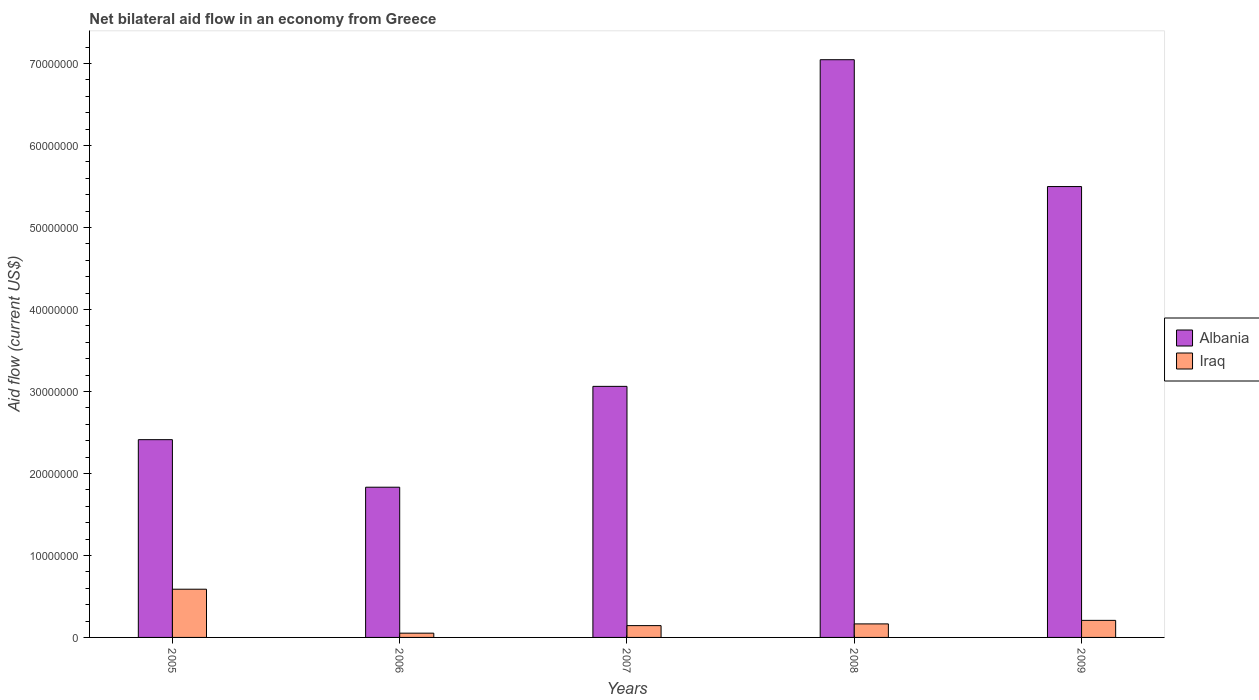How many different coloured bars are there?
Ensure brevity in your answer.  2. How many groups of bars are there?
Give a very brief answer. 5. Are the number of bars per tick equal to the number of legend labels?
Your answer should be compact. Yes. Are the number of bars on each tick of the X-axis equal?
Provide a succinct answer. Yes. What is the label of the 4th group of bars from the left?
Provide a short and direct response. 2008. In how many cases, is the number of bars for a given year not equal to the number of legend labels?
Offer a terse response. 0. What is the net bilateral aid flow in Albania in 2005?
Your response must be concise. 2.41e+07. Across all years, what is the maximum net bilateral aid flow in Iraq?
Make the answer very short. 5.88e+06. Across all years, what is the minimum net bilateral aid flow in Albania?
Offer a terse response. 1.83e+07. In which year was the net bilateral aid flow in Iraq minimum?
Give a very brief answer. 2006. What is the total net bilateral aid flow in Iraq in the graph?
Offer a terse response. 1.16e+07. What is the difference between the net bilateral aid flow in Iraq in 2008 and that in 2009?
Ensure brevity in your answer.  -4.30e+05. What is the difference between the net bilateral aid flow in Albania in 2005 and the net bilateral aid flow in Iraq in 2009?
Ensure brevity in your answer.  2.20e+07. What is the average net bilateral aid flow in Iraq per year?
Provide a short and direct response. 2.31e+06. In the year 2009, what is the difference between the net bilateral aid flow in Iraq and net bilateral aid flow in Albania?
Ensure brevity in your answer.  -5.29e+07. What is the ratio of the net bilateral aid flow in Iraq in 2007 to that in 2009?
Keep it short and to the point. 0.69. Is the difference between the net bilateral aid flow in Iraq in 2005 and 2008 greater than the difference between the net bilateral aid flow in Albania in 2005 and 2008?
Offer a terse response. Yes. What is the difference between the highest and the second highest net bilateral aid flow in Iraq?
Provide a short and direct response. 3.80e+06. What is the difference between the highest and the lowest net bilateral aid flow in Iraq?
Offer a terse response. 5.36e+06. Is the sum of the net bilateral aid flow in Albania in 2007 and 2009 greater than the maximum net bilateral aid flow in Iraq across all years?
Provide a succinct answer. Yes. What does the 2nd bar from the left in 2008 represents?
Your answer should be compact. Iraq. What does the 1st bar from the right in 2005 represents?
Offer a very short reply. Iraq. Are all the bars in the graph horizontal?
Provide a short and direct response. No. What is the difference between two consecutive major ticks on the Y-axis?
Your response must be concise. 1.00e+07. Does the graph contain grids?
Make the answer very short. No. Where does the legend appear in the graph?
Your response must be concise. Center right. What is the title of the graph?
Your answer should be compact. Net bilateral aid flow in an economy from Greece. Does "Puerto Rico" appear as one of the legend labels in the graph?
Your response must be concise. No. What is the label or title of the Y-axis?
Make the answer very short. Aid flow (current US$). What is the Aid flow (current US$) of Albania in 2005?
Your answer should be compact. 2.41e+07. What is the Aid flow (current US$) of Iraq in 2005?
Your answer should be very brief. 5.88e+06. What is the Aid flow (current US$) in Albania in 2006?
Offer a terse response. 1.83e+07. What is the Aid flow (current US$) in Iraq in 2006?
Provide a succinct answer. 5.20e+05. What is the Aid flow (current US$) of Albania in 2007?
Your response must be concise. 3.06e+07. What is the Aid flow (current US$) of Iraq in 2007?
Your response must be concise. 1.44e+06. What is the Aid flow (current US$) in Albania in 2008?
Your answer should be compact. 7.05e+07. What is the Aid flow (current US$) of Iraq in 2008?
Keep it short and to the point. 1.65e+06. What is the Aid flow (current US$) of Albania in 2009?
Offer a terse response. 5.50e+07. What is the Aid flow (current US$) in Iraq in 2009?
Ensure brevity in your answer.  2.08e+06. Across all years, what is the maximum Aid flow (current US$) in Albania?
Give a very brief answer. 7.05e+07. Across all years, what is the maximum Aid flow (current US$) of Iraq?
Your response must be concise. 5.88e+06. Across all years, what is the minimum Aid flow (current US$) of Albania?
Make the answer very short. 1.83e+07. Across all years, what is the minimum Aid flow (current US$) of Iraq?
Keep it short and to the point. 5.20e+05. What is the total Aid flow (current US$) in Albania in the graph?
Offer a terse response. 1.99e+08. What is the total Aid flow (current US$) in Iraq in the graph?
Your response must be concise. 1.16e+07. What is the difference between the Aid flow (current US$) in Albania in 2005 and that in 2006?
Your answer should be very brief. 5.80e+06. What is the difference between the Aid flow (current US$) of Iraq in 2005 and that in 2006?
Your answer should be compact. 5.36e+06. What is the difference between the Aid flow (current US$) in Albania in 2005 and that in 2007?
Keep it short and to the point. -6.50e+06. What is the difference between the Aid flow (current US$) of Iraq in 2005 and that in 2007?
Provide a succinct answer. 4.44e+06. What is the difference between the Aid flow (current US$) of Albania in 2005 and that in 2008?
Your response must be concise. -4.63e+07. What is the difference between the Aid flow (current US$) in Iraq in 2005 and that in 2008?
Keep it short and to the point. 4.23e+06. What is the difference between the Aid flow (current US$) in Albania in 2005 and that in 2009?
Your answer should be very brief. -3.09e+07. What is the difference between the Aid flow (current US$) in Iraq in 2005 and that in 2009?
Give a very brief answer. 3.80e+06. What is the difference between the Aid flow (current US$) of Albania in 2006 and that in 2007?
Provide a short and direct response. -1.23e+07. What is the difference between the Aid flow (current US$) of Iraq in 2006 and that in 2007?
Give a very brief answer. -9.20e+05. What is the difference between the Aid flow (current US$) in Albania in 2006 and that in 2008?
Keep it short and to the point. -5.21e+07. What is the difference between the Aid flow (current US$) of Iraq in 2006 and that in 2008?
Give a very brief answer. -1.13e+06. What is the difference between the Aid flow (current US$) of Albania in 2006 and that in 2009?
Ensure brevity in your answer.  -3.67e+07. What is the difference between the Aid flow (current US$) of Iraq in 2006 and that in 2009?
Your answer should be compact. -1.56e+06. What is the difference between the Aid flow (current US$) in Albania in 2007 and that in 2008?
Ensure brevity in your answer.  -3.98e+07. What is the difference between the Aid flow (current US$) in Albania in 2007 and that in 2009?
Offer a very short reply. -2.44e+07. What is the difference between the Aid flow (current US$) in Iraq in 2007 and that in 2009?
Offer a very short reply. -6.40e+05. What is the difference between the Aid flow (current US$) of Albania in 2008 and that in 2009?
Make the answer very short. 1.55e+07. What is the difference between the Aid flow (current US$) in Iraq in 2008 and that in 2009?
Your answer should be compact. -4.30e+05. What is the difference between the Aid flow (current US$) in Albania in 2005 and the Aid flow (current US$) in Iraq in 2006?
Provide a short and direct response. 2.36e+07. What is the difference between the Aid flow (current US$) in Albania in 2005 and the Aid flow (current US$) in Iraq in 2007?
Offer a terse response. 2.27e+07. What is the difference between the Aid flow (current US$) of Albania in 2005 and the Aid flow (current US$) of Iraq in 2008?
Offer a terse response. 2.25e+07. What is the difference between the Aid flow (current US$) of Albania in 2005 and the Aid flow (current US$) of Iraq in 2009?
Make the answer very short. 2.20e+07. What is the difference between the Aid flow (current US$) of Albania in 2006 and the Aid flow (current US$) of Iraq in 2007?
Keep it short and to the point. 1.69e+07. What is the difference between the Aid flow (current US$) of Albania in 2006 and the Aid flow (current US$) of Iraq in 2008?
Make the answer very short. 1.67e+07. What is the difference between the Aid flow (current US$) in Albania in 2006 and the Aid flow (current US$) in Iraq in 2009?
Provide a short and direct response. 1.62e+07. What is the difference between the Aid flow (current US$) of Albania in 2007 and the Aid flow (current US$) of Iraq in 2008?
Provide a short and direct response. 2.90e+07. What is the difference between the Aid flow (current US$) of Albania in 2007 and the Aid flow (current US$) of Iraq in 2009?
Your answer should be compact. 2.85e+07. What is the difference between the Aid flow (current US$) in Albania in 2008 and the Aid flow (current US$) in Iraq in 2009?
Provide a succinct answer. 6.84e+07. What is the average Aid flow (current US$) of Albania per year?
Provide a succinct answer. 3.97e+07. What is the average Aid flow (current US$) of Iraq per year?
Ensure brevity in your answer.  2.31e+06. In the year 2005, what is the difference between the Aid flow (current US$) of Albania and Aid flow (current US$) of Iraq?
Your response must be concise. 1.82e+07. In the year 2006, what is the difference between the Aid flow (current US$) of Albania and Aid flow (current US$) of Iraq?
Offer a very short reply. 1.78e+07. In the year 2007, what is the difference between the Aid flow (current US$) of Albania and Aid flow (current US$) of Iraq?
Make the answer very short. 2.92e+07. In the year 2008, what is the difference between the Aid flow (current US$) of Albania and Aid flow (current US$) of Iraq?
Make the answer very short. 6.88e+07. In the year 2009, what is the difference between the Aid flow (current US$) of Albania and Aid flow (current US$) of Iraq?
Your answer should be very brief. 5.29e+07. What is the ratio of the Aid flow (current US$) of Albania in 2005 to that in 2006?
Make the answer very short. 1.32. What is the ratio of the Aid flow (current US$) in Iraq in 2005 to that in 2006?
Offer a very short reply. 11.31. What is the ratio of the Aid flow (current US$) of Albania in 2005 to that in 2007?
Offer a very short reply. 0.79. What is the ratio of the Aid flow (current US$) of Iraq in 2005 to that in 2007?
Your answer should be compact. 4.08. What is the ratio of the Aid flow (current US$) of Albania in 2005 to that in 2008?
Make the answer very short. 0.34. What is the ratio of the Aid flow (current US$) in Iraq in 2005 to that in 2008?
Your answer should be very brief. 3.56. What is the ratio of the Aid flow (current US$) in Albania in 2005 to that in 2009?
Your response must be concise. 0.44. What is the ratio of the Aid flow (current US$) of Iraq in 2005 to that in 2009?
Give a very brief answer. 2.83. What is the ratio of the Aid flow (current US$) of Albania in 2006 to that in 2007?
Provide a short and direct response. 0.6. What is the ratio of the Aid flow (current US$) in Iraq in 2006 to that in 2007?
Provide a short and direct response. 0.36. What is the ratio of the Aid flow (current US$) of Albania in 2006 to that in 2008?
Keep it short and to the point. 0.26. What is the ratio of the Aid flow (current US$) in Iraq in 2006 to that in 2008?
Your answer should be compact. 0.32. What is the ratio of the Aid flow (current US$) in Albania in 2006 to that in 2009?
Make the answer very short. 0.33. What is the ratio of the Aid flow (current US$) of Iraq in 2006 to that in 2009?
Offer a terse response. 0.25. What is the ratio of the Aid flow (current US$) in Albania in 2007 to that in 2008?
Make the answer very short. 0.43. What is the ratio of the Aid flow (current US$) in Iraq in 2007 to that in 2008?
Keep it short and to the point. 0.87. What is the ratio of the Aid flow (current US$) in Albania in 2007 to that in 2009?
Keep it short and to the point. 0.56. What is the ratio of the Aid flow (current US$) of Iraq in 2007 to that in 2009?
Give a very brief answer. 0.69. What is the ratio of the Aid flow (current US$) of Albania in 2008 to that in 2009?
Your response must be concise. 1.28. What is the ratio of the Aid flow (current US$) of Iraq in 2008 to that in 2009?
Make the answer very short. 0.79. What is the difference between the highest and the second highest Aid flow (current US$) in Albania?
Your response must be concise. 1.55e+07. What is the difference between the highest and the second highest Aid flow (current US$) in Iraq?
Your answer should be compact. 3.80e+06. What is the difference between the highest and the lowest Aid flow (current US$) in Albania?
Your response must be concise. 5.21e+07. What is the difference between the highest and the lowest Aid flow (current US$) in Iraq?
Ensure brevity in your answer.  5.36e+06. 